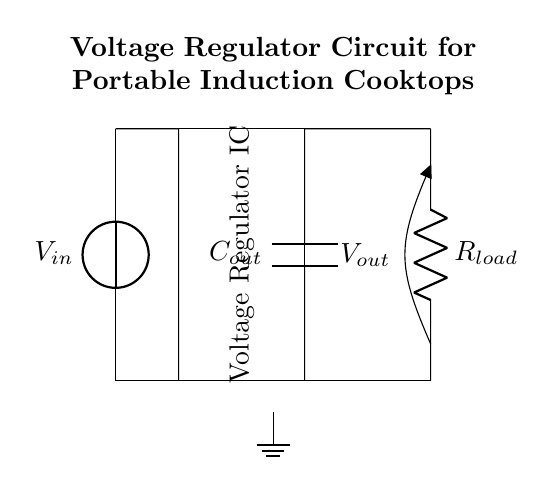What is the input voltage of this circuit? The input voltage is represented by the symbol V in the circuit diagram, denoted by the voltage source with label Vin at the left side of the diagram.
Answer: Vin What type of component is the central rectangle in the circuit? The central rectangle in the circuit diagram represents the voltage regulator IC, which is responsible for maintaining a consistent output voltage despite variations in input voltage. It is labeled as "Voltage Regulator IC" in the diagram.
Answer: Voltage Regulator IC What is connected to the output of the voltage regulator? The output of the voltage regulator is connected to the output capacitor labeled Cout and subsequently to the load resistor Rload, indicating that it serves as a power supply for the load.
Answer: Cout and Rload What is the purpose of the output capacitor in this circuit? The output capacitor, labeled Cout, stabilizes the output voltage by smoothing any fluctuations or spikes in the voltage supplied to the load, improving performance during operation.
Answer: Stabilization How does the output voltage relate to the input voltage? The output voltage Vout is determined by the voltage regulator IC, which steps down or regulates the input voltage Vin to a predetermined level suitable for the load connected. The exact relationship depends on the specifications of the regulator being utilized.
Answer: Regulated What would likely happen if the load resistance was too low? If the load resistance Rload is too low, it could draw excessive current from the circuit, possibly leading to overheating or damage to the voltage regulator IC, potentially resulting in circuit failure or reduced performance.
Answer: Excessive current 